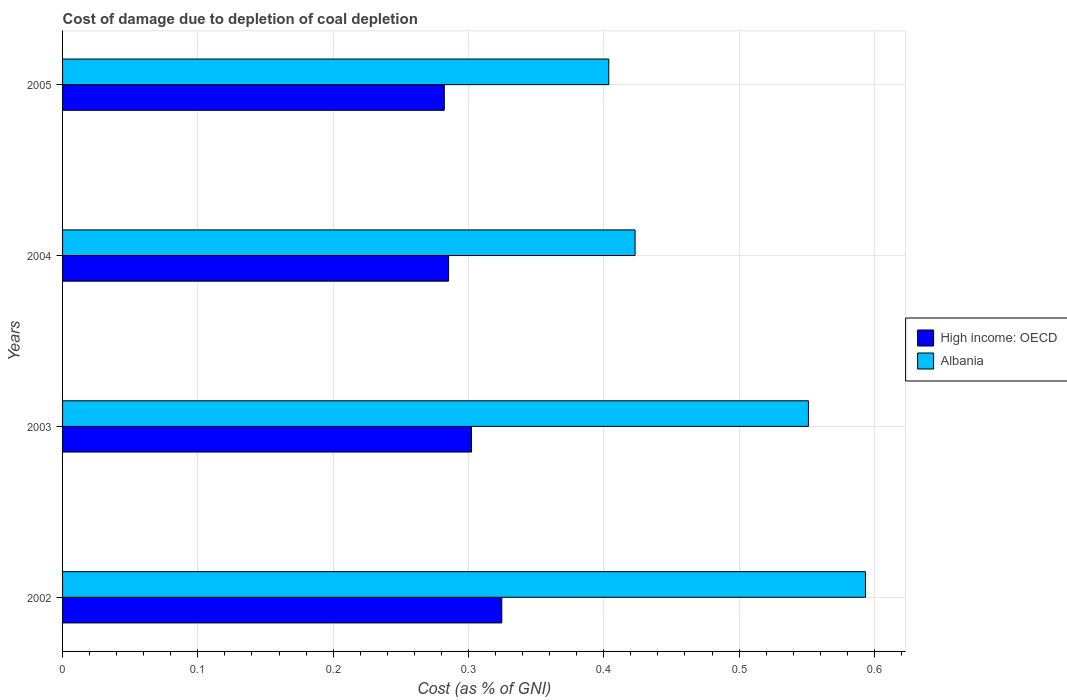How many groups of bars are there?
Your answer should be compact. 4. How many bars are there on the 1st tick from the top?
Provide a succinct answer. 2. How many bars are there on the 3rd tick from the bottom?
Your response must be concise. 2. In how many cases, is the number of bars for a given year not equal to the number of legend labels?
Provide a succinct answer. 0. What is the cost of damage caused due to coal depletion in High income: OECD in 2005?
Provide a succinct answer. 0.28. Across all years, what is the maximum cost of damage caused due to coal depletion in Albania?
Ensure brevity in your answer.  0.59. Across all years, what is the minimum cost of damage caused due to coal depletion in Albania?
Keep it short and to the point. 0.4. In which year was the cost of damage caused due to coal depletion in High income: OECD maximum?
Make the answer very short. 2002. What is the total cost of damage caused due to coal depletion in High income: OECD in the graph?
Offer a terse response. 1.19. What is the difference between the cost of damage caused due to coal depletion in Albania in 2003 and that in 2004?
Your response must be concise. 0.13. What is the difference between the cost of damage caused due to coal depletion in High income: OECD in 2004 and the cost of damage caused due to coal depletion in Albania in 2003?
Provide a short and direct response. -0.27. What is the average cost of damage caused due to coal depletion in High income: OECD per year?
Your answer should be very brief. 0.3. In the year 2003, what is the difference between the cost of damage caused due to coal depletion in Albania and cost of damage caused due to coal depletion in High income: OECD?
Your answer should be compact. 0.25. In how many years, is the cost of damage caused due to coal depletion in Albania greater than 0.06 %?
Offer a terse response. 4. What is the ratio of the cost of damage caused due to coal depletion in High income: OECD in 2002 to that in 2004?
Ensure brevity in your answer.  1.14. Is the cost of damage caused due to coal depletion in Albania in 2004 less than that in 2005?
Your response must be concise. No. What is the difference between the highest and the second highest cost of damage caused due to coal depletion in Albania?
Ensure brevity in your answer.  0.04. What is the difference between the highest and the lowest cost of damage caused due to coal depletion in High income: OECD?
Offer a very short reply. 0.04. In how many years, is the cost of damage caused due to coal depletion in High income: OECD greater than the average cost of damage caused due to coal depletion in High income: OECD taken over all years?
Provide a succinct answer. 2. What does the 1st bar from the top in 2005 represents?
Ensure brevity in your answer.  Albania. What does the 1st bar from the bottom in 2002 represents?
Offer a very short reply. High income: OECD. How many bars are there?
Offer a terse response. 8. What is the difference between two consecutive major ticks on the X-axis?
Provide a succinct answer. 0.1. Are the values on the major ticks of X-axis written in scientific E-notation?
Offer a terse response. No. Where does the legend appear in the graph?
Make the answer very short. Center right. How many legend labels are there?
Your answer should be compact. 2. What is the title of the graph?
Provide a short and direct response. Cost of damage due to depletion of coal depletion. Does "Samoa" appear as one of the legend labels in the graph?
Offer a terse response. No. What is the label or title of the X-axis?
Offer a very short reply. Cost (as % of GNI). What is the label or title of the Y-axis?
Provide a short and direct response. Years. What is the Cost (as % of GNI) of High income: OECD in 2002?
Your response must be concise. 0.32. What is the Cost (as % of GNI) of Albania in 2002?
Ensure brevity in your answer.  0.59. What is the Cost (as % of GNI) in High income: OECD in 2003?
Your answer should be compact. 0.3. What is the Cost (as % of GNI) of Albania in 2003?
Give a very brief answer. 0.55. What is the Cost (as % of GNI) in High income: OECD in 2004?
Keep it short and to the point. 0.29. What is the Cost (as % of GNI) in Albania in 2004?
Keep it short and to the point. 0.42. What is the Cost (as % of GNI) of High income: OECD in 2005?
Provide a short and direct response. 0.28. What is the Cost (as % of GNI) in Albania in 2005?
Your answer should be compact. 0.4. Across all years, what is the maximum Cost (as % of GNI) of High income: OECD?
Ensure brevity in your answer.  0.32. Across all years, what is the maximum Cost (as % of GNI) in Albania?
Offer a terse response. 0.59. Across all years, what is the minimum Cost (as % of GNI) of High income: OECD?
Ensure brevity in your answer.  0.28. Across all years, what is the minimum Cost (as % of GNI) in Albania?
Your answer should be very brief. 0.4. What is the total Cost (as % of GNI) of High income: OECD in the graph?
Give a very brief answer. 1.19. What is the total Cost (as % of GNI) of Albania in the graph?
Your answer should be very brief. 1.97. What is the difference between the Cost (as % of GNI) of High income: OECD in 2002 and that in 2003?
Your answer should be very brief. 0.02. What is the difference between the Cost (as % of GNI) in Albania in 2002 and that in 2003?
Keep it short and to the point. 0.04. What is the difference between the Cost (as % of GNI) in High income: OECD in 2002 and that in 2004?
Make the answer very short. 0.04. What is the difference between the Cost (as % of GNI) in Albania in 2002 and that in 2004?
Provide a succinct answer. 0.17. What is the difference between the Cost (as % of GNI) of High income: OECD in 2002 and that in 2005?
Offer a terse response. 0.04. What is the difference between the Cost (as % of GNI) of Albania in 2002 and that in 2005?
Ensure brevity in your answer.  0.19. What is the difference between the Cost (as % of GNI) of High income: OECD in 2003 and that in 2004?
Offer a terse response. 0.02. What is the difference between the Cost (as % of GNI) in Albania in 2003 and that in 2004?
Make the answer very short. 0.13. What is the difference between the Cost (as % of GNI) in High income: OECD in 2003 and that in 2005?
Provide a succinct answer. 0.02. What is the difference between the Cost (as % of GNI) in Albania in 2003 and that in 2005?
Make the answer very short. 0.15. What is the difference between the Cost (as % of GNI) of High income: OECD in 2004 and that in 2005?
Provide a short and direct response. 0. What is the difference between the Cost (as % of GNI) of Albania in 2004 and that in 2005?
Your answer should be very brief. 0.02. What is the difference between the Cost (as % of GNI) in High income: OECD in 2002 and the Cost (as % of GNI) in Albania in 2003?
Your answer should be very brief. -0.23. What is the difference between the Cost (as % of GNI) in High income: OECD in 2002 and the Cost (as % of GNI) in Albania in 2004?
Make the answer very short. -0.1. What is the difference between the Cost (as % of GNI) of High income: OECD in 2002 and the Cost (as % of GNI) of Albania in 2005?
Your response must be concise. -0.08. What is the difference between the Cost (as % of GNI) of High income: OECD in 2003 and the Cost (as % of GNI) of Albania in 2004?
Provide a short and direct response. -0.12. What is the difference between the Cost (as % of GNI) of High income: OECD in 2003 and the Cost (as % of GNI) of Albania in 2005?
Provide a succinct answer. -0.1. What is the difference between the Cost (as % of GNI) in High income: OECD in 2004 and the Cost (as % of GNI) in Albania in 2005?
Give a very brief answer. -0.12. What is the average Cost (as % of GNI) of High income: OECD per year?
Provide a short and direct response. 0.3. What is the average Cost (as % of GNI) of Albania per year?
Ensure brevity in your answer.  0.49. In the year 2002, what is the difference between the Cost (as % of GNI) of High income: OECD and Cost (as % of GNI) of Albania?
Ensure brevity in your answer.  -0.27. In the year 2003, what is the difference between the Cost (as % of GNI) in High income: OECD and Cost (as % of GNI) in Albania?
Ensure brevity in your answer.  -0.25. In the year 2004, what is the difference between the Cost (as % of GNI) of High income: OECD and Cost (as % of GNI) of Albania?
Ensure brevity in your answer.  -0.14. In the year 2005, what is the difference between the Cost (as % of GNI) of High income: OECD and Cost (as % of GNI) of Albania?
Provide a short and direct response. -0.12. What is the ratio of the Cost (as % of GNI) in High income: OECD in 2002 to that in 2003?
Your answer should be compact. 1.07. What is the ratio of the Cost (as % of GNI) in Albania in 2002 to that in 2003?
Provide a short and direct response. 1.08. What is the ratio of the Cost (as % of GNI) of High income: OECD in 2002 to that in 2004?
Your answer should be very brief. 1.14. What is the ratio of the Cost (as % of GNI) of Albania in 2002 to that in 2004?
Provide a short and direct response. 1.4. What is the ratio of the Cost (as % of GNI) of High income: OECD in 2002 to that in 2005?
Give a very brief answer. 1.15. What is the ratio of the Cost (as % of GNI) of Albania in 2002 to that in 2005?
Your answer should be compact. 1.47. What is the ratio of the Cost (as % of GNI) of High income: OECD in 2003 to that in 2004?
Ensure brevity in your answer.  1.06. What is the ratio of the Cost (as % of GNI) of Albania in 2003 to that in 2004?
Give a very brief answer. 1.3. What is the ratio of the Cost (as % of GNI) of High income: OECD in 2003 to that in 2005?
Ensure brevity in your answer.  1.07. What is the ratio of the Cost (as % of GNI) in Albania in 2003 to that in 2005?
Ensure brevity in your answer.  1.37. What is the ratio of the Cost (as % of GNI) in High income: OECD in 2004 to that in 2005?
Your response must be concise. 1.01. What is the ratio of the Cost (as % of GNI) in Albania in 2004 to that in 2005?
Your response must be concise. 1.05. What is the difference between the highest and the second highest Cost (as % of GNI) of High income: OECD?
Your answer should be very brief. 0.02. What is the difference between the highest and the second highest Cost (as % of GNI) of Albania?
Give a very brief answer. 0.04. What is the difference between the highest and the lowest Cost (as % of GNI) in High income: OECD?
Your answer should be compact. 0.04. What is the difference between the highest and the lowest Cost (as % of GNI) of Albania?
Your response must be concise. 0.19. 